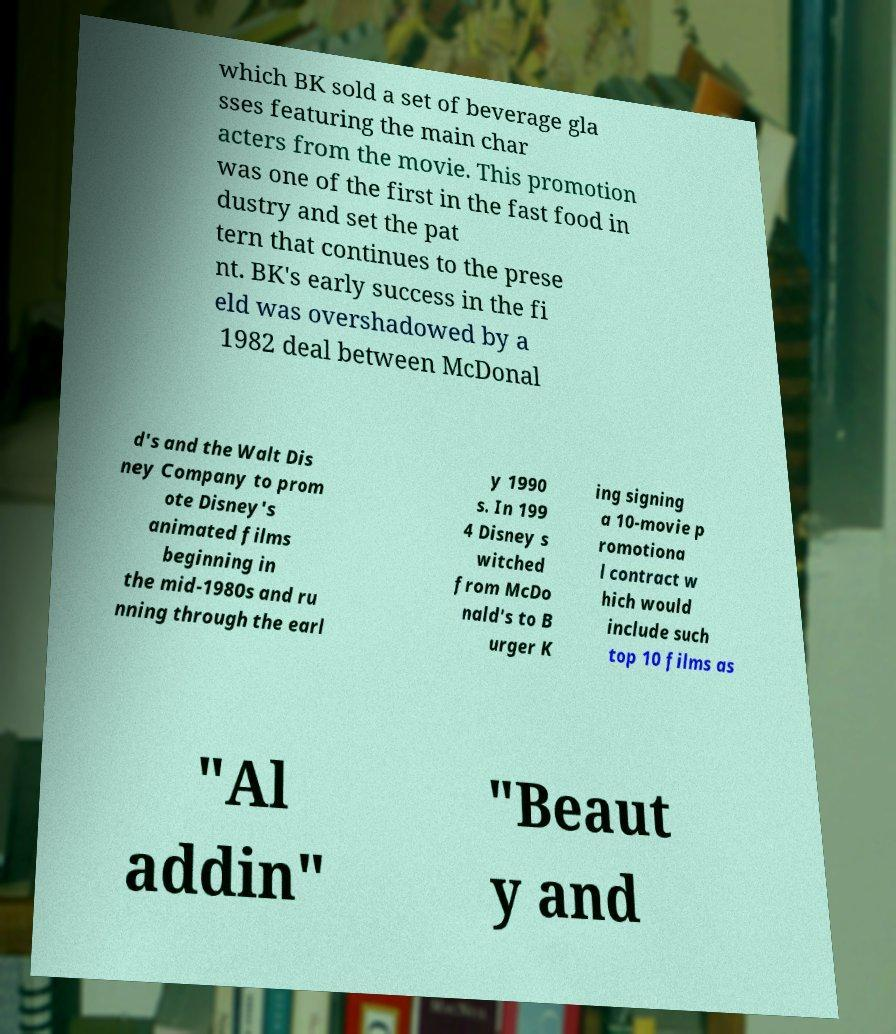There's text embedded in this image that I need extracted. Can you transcribe it verbatim? which BK sold a set of beverage gla sses featuring the main char acters from the movie. This promotion was one of the first in the fast food in dustry and set the pat tern that continues to the prese nt. BK's early success in the fi eld was overshadowed by a 1982 deal between McDonal d's and the Walt Dis ney Company to prom ote Disney's animated films beginning in the mid-1980s and ru nning through the earl y 1990 s. In 199 4 Disney s witched from McDo nald's to B urger K ing signing a 10-movie p romotiona l contract w hich would include such top 10 films as "Al addin" "Beaut y and 